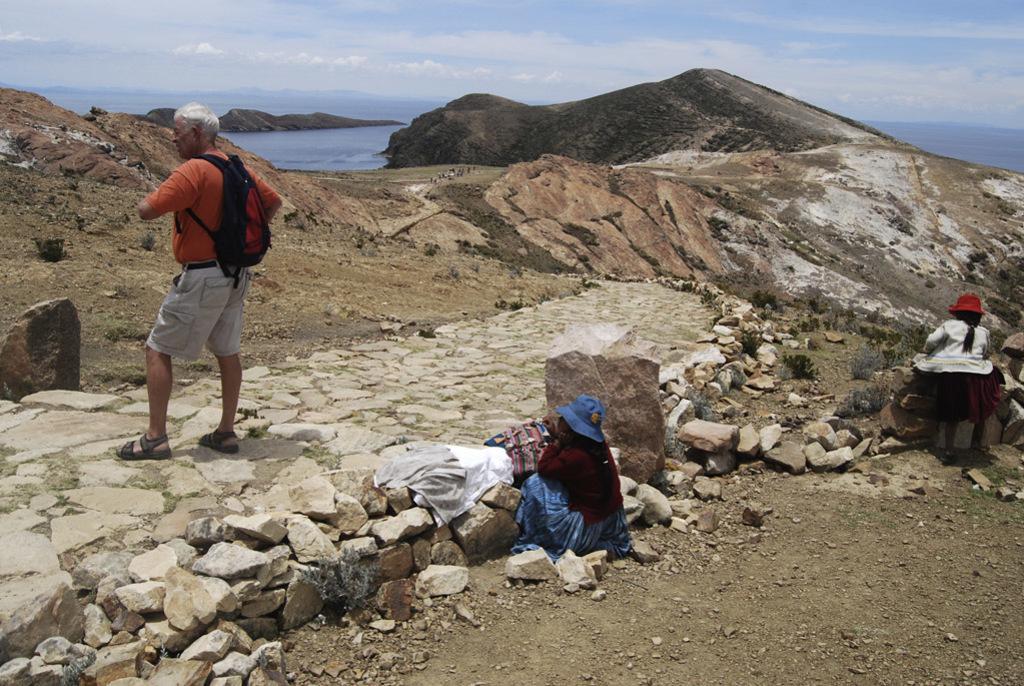In one or two sentences, can you explain what this image depicts? In the middle of the image three persons are standing and sitting on a hill and we can see some stones. At the top of the image we can see some clouds in the sky. Behind the hill we can see water. 